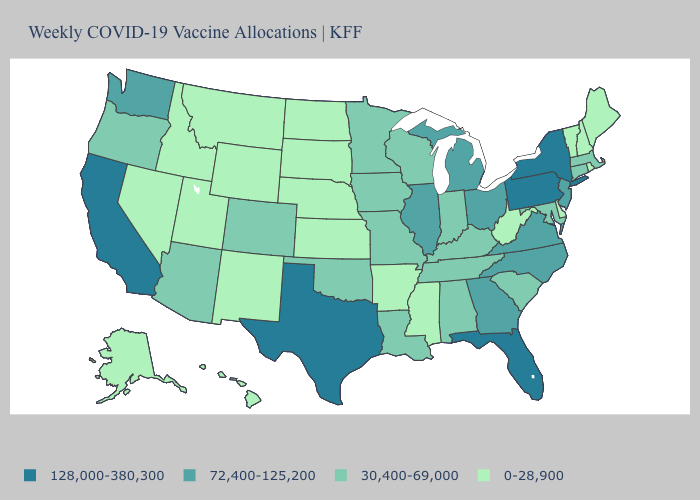How many symbols are there in the legend?
Short answer required. 4. Does Connecticut have the lowest value in the Northeast?
Keep it brief. No. Name the states that have a value in the range 0-28,900?
Be succinct. Alaska, Arkansas, Delaware, Hawaii, Idaho, Kansas, Maine, Mississippi, Montana, Nebraska, Nevada, New Hampshire, New Mexico, North Dakota, Rhode Island, South Dakota, Utah, Vermont, West Virginia, Wyoming. What is the value of Vermont?
Concise answer only. 0-28,900. Name the states that have a value in the range 30,400-69,000?
Short answer required. Alabama, Arizona, Colorado, Connecticut, Indiana, Iowa, Kentucky, Louisiana, Maryland, Massachusetts, Minnesota, Missouri, Oklahoma, Oregon, South Carolina, Tennessee, Wisconsin. How many symbols are there in the legend?
Answer briefly. 4. Among the states that border South Dakota , does Nebraska have the highest value?
Be succinct. No. Is the legend a continuous bar?
Short answer required. No. Name the states that have a value in the range 128,000-380,300?
Short answer required. California, Florida, New York, Pennsylvania, Texas. Does Illinois have the highest value in the MidWest?
Keep it brief. Yes. Among the states that border South Dakota , which have the highest value?
Give a very brief answer. Iowa, Minnesota. Does Minnesota have a higher value than Washington?
Answer briefly. No. What is the value of Texas?
Short answer required. 128,000-380,300. Name the states that have a value in the range 72,400-125,200?
Keep it brief. Georgia, Illinois, Michigan, New Jersey, North Carolina, Ohio, Virginia, Washington. Name the states that have a value in the range 0-28,900?
Write a very short answer. Alaska, Arkansas, Delaware, Hawaii, Idaho, Kansas, Maine, Mississippi, Montana, Nebraska, Nevada, New Hampshire, New Mexico, North Dakota, Rhode Island, South Dakota, Utah, Vermont, West Virginia, Wyoming. 